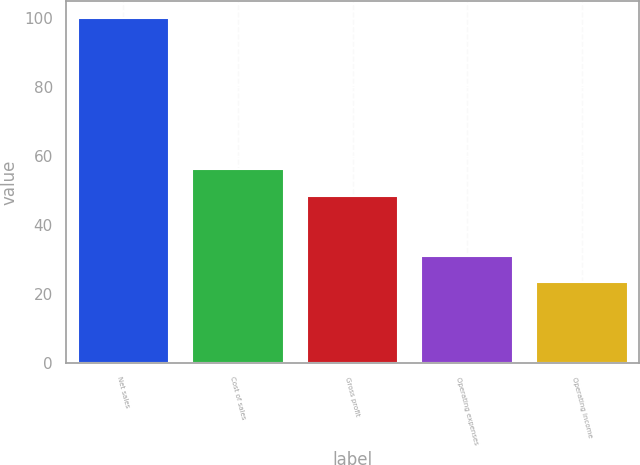<chart> <loc_0><loc_0><loc_500><loc_500><bar_chart><fcel>Net sales<fcel>Cost of sales<fcel>Gross profit<fcel>Operating expenses<fcel>Operating income<nl><fcel>100<fcel>56.16<fcel>48.5<fcel>31.06<fcel>23.4<nl></chart> 